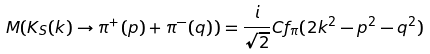<formula> <loc_0><loc_0><loc_500><loc_500>M ( K _ { S } ( k ) \rightarrow \pi ^ { + } ( p ) + \pi ^ { - } ( q ) ) = \frac { i } { \sqrt { 2 } } C f _ { \pi } ( 2 k ^ { 2 } - p ^ { 2 } - q ^ { 2 } )</formula> 